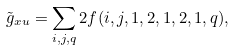<formula> <loc_0><loc_0><loc_500><loc_500>\tilde { g } _ { x u } = \sum _ { i , j , q } 2 f ( i , j , 1 , 2 , 1 , 2 , 1 , q ) ,</formula> 